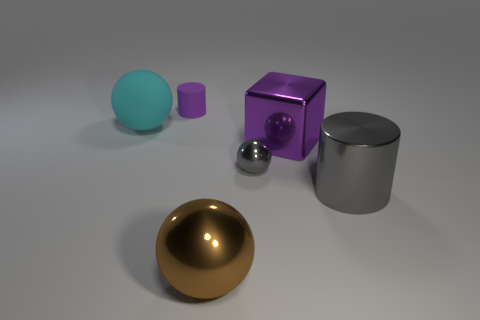Add 2 large cyan rubber balls. How many objects exist? 8 Subtract all blocks. How many objects are left? 5 Subtract all tiny purple matte cubes. Subtract all brown spheres. How many objects are left? 5 Add 2 shiny cylinders. How many shiny cylinders are left? 3 Add 6 big spheres. How many big spheres exist? 8 Subtract 0 green cubes. How many objects are left? 6 